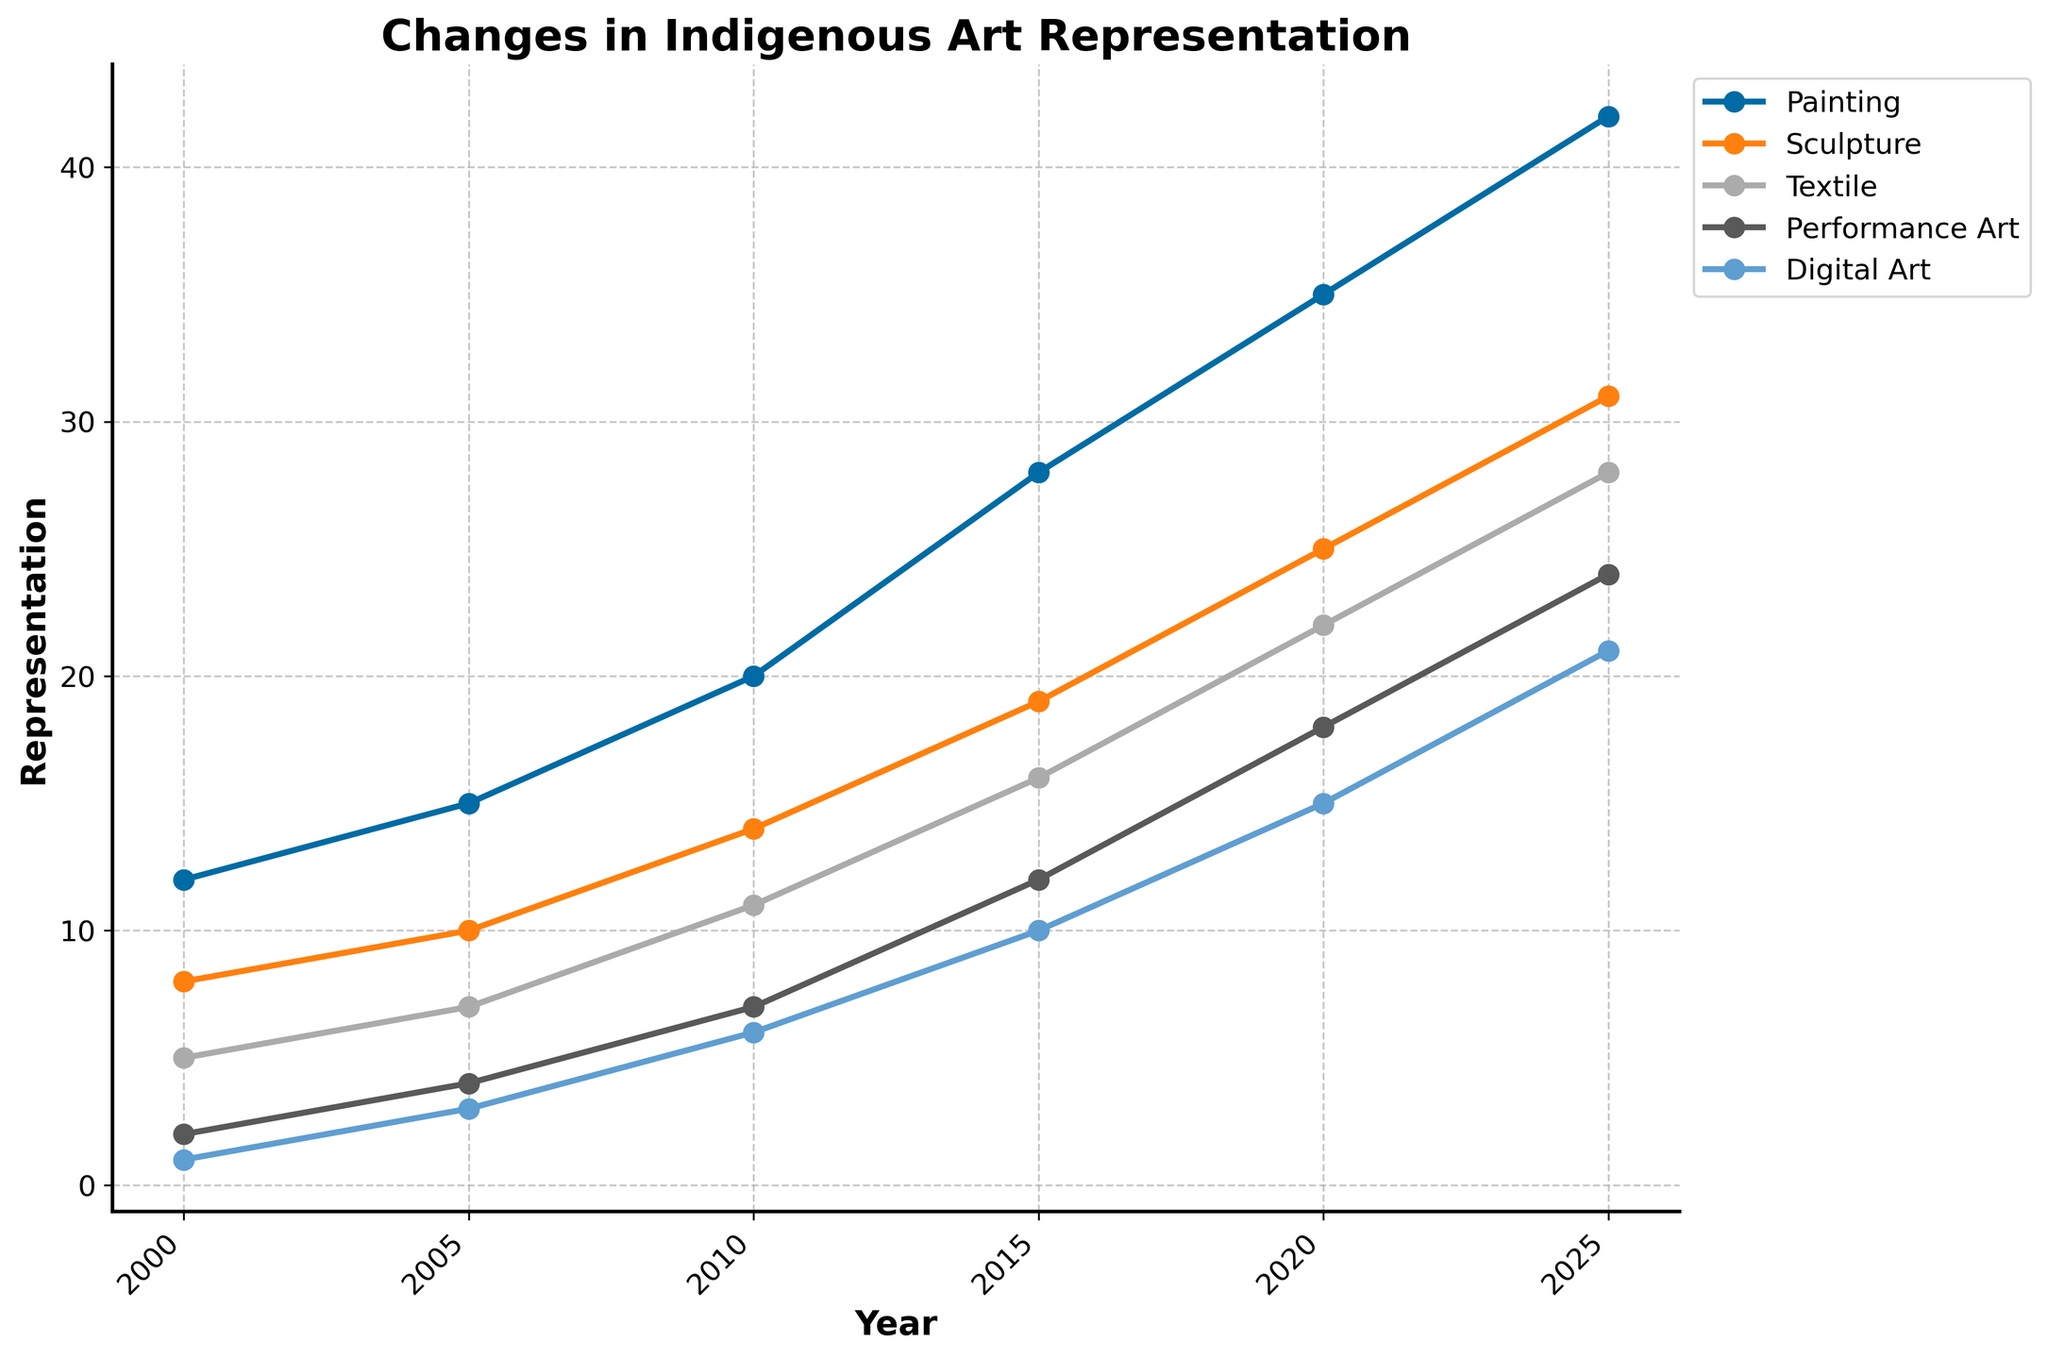What art form had the highest representation in 2020? Look at the data points for the year 2020, and compare the values of each art form. Painting has the highest representation with a value of 35.
Answer: Painting What is the difference in the representation of Textile art between 2005 and 2015? Subtract the value of Textile art in 2005 (7) from its value in 2015 (16). The difference is 16 - 7.
Answer: 9 Which art form had the least growth from 2000 to 2025? Compare the values of each art form in 2000 and 2025, and calculate the difference for each. Performance Art grows from 2 to 24, and Digital Art grows from 1 to 21. Even though Performance Art starts at a higher value, Digital Art has a lower overall growth (21 - 1 = 20 compared to 24 - 2 = 22). Hence, Digital Art had the least growth.
Answer: Digital Art Between 2000 and 2025, how many more representations does Sculpture have compared to Textile art? For 2025, the representation values are 31 for Sculpture and 28 for Textile. The difference is 31 - 28.
Answer: 3 Did any art form have a consistent increase in representation every five years? Observe all art forms across each year (2000, 2005, 2010, 2015, 2020, 2025). Every art form shows a steady rise in each time interval, indicating a consistent increase.
Answer: Yes What is the average representation of Performance Art over the years shown? Calculate the mean value by adding up all representation values of Performance Art (2, 4, 7, 12, 18, 24) and dividing by the number of years (6). The total is 2 + 4 + 7 + 12 + 18 + 24 = 67, so the average is 67 / 6.
Answer: 11.17 Which year saw the highest increase in the representation of Digital Art compared to the previous five years? Calculate the differences between consecutive five-year intervals for Digital Art (2000-2005, 2005-2010, ... 2020-2025). The increases are 3, 3, 4, 5, and 6 respectively. The highest increase (6) occurred between 2020 and 2025.
Answer: 2025 How much total representation did all art forms have in 2010? Add up the representation values for each art form in 2010, which are 20, 14, 11, 7, and 6. The total is 20 + 14 + 11 + 7 + 6.
Answer: 58 Between 2010 and 2015, which art form had the largest increase in representation? Calculate the differences between 2015 and 2010 for each art form. Painting: 28 - 20 = 8; Sculpture: 19 - 14 = 5; Textile: 16 - 11 = 5; Performance Art: 12 - 7 = 5; Digital Art: 10 - 6 = 4. Painting had the largest increase of 8.
Answer: Painting What is the average annual growth rate of Sculpture from 2000 to 2025? Calculate the absolute growth of Sculpture (31 - 8 = 23), then divide by the number of years (2025 - 2000 = 25). The average annual growth rate is 23 / 25.
Answer: 0.92 